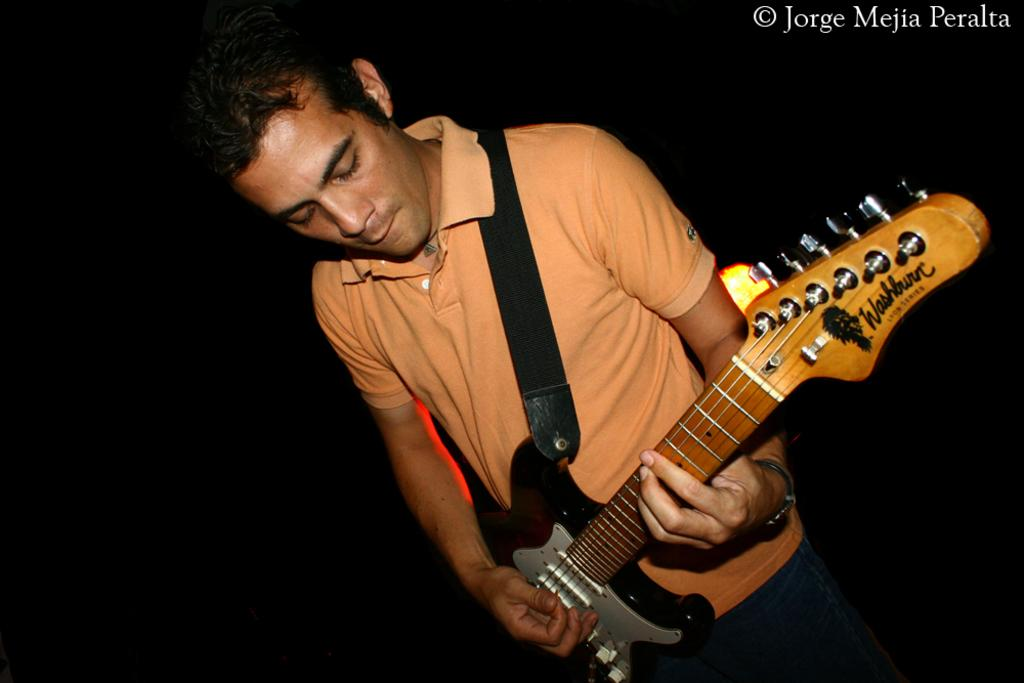What is the main subject of the image? The main subject of the image is a man. What is the man holding in the image? The man is holding a guitar in the image. What is the man's posture in the image? The man is standing in the image. What type of knowledge can be seen rolling on the ground in the image? There is no knowledge or rolling object present in the image. Is there an apple visible in the image? There is no apple present in the image. 